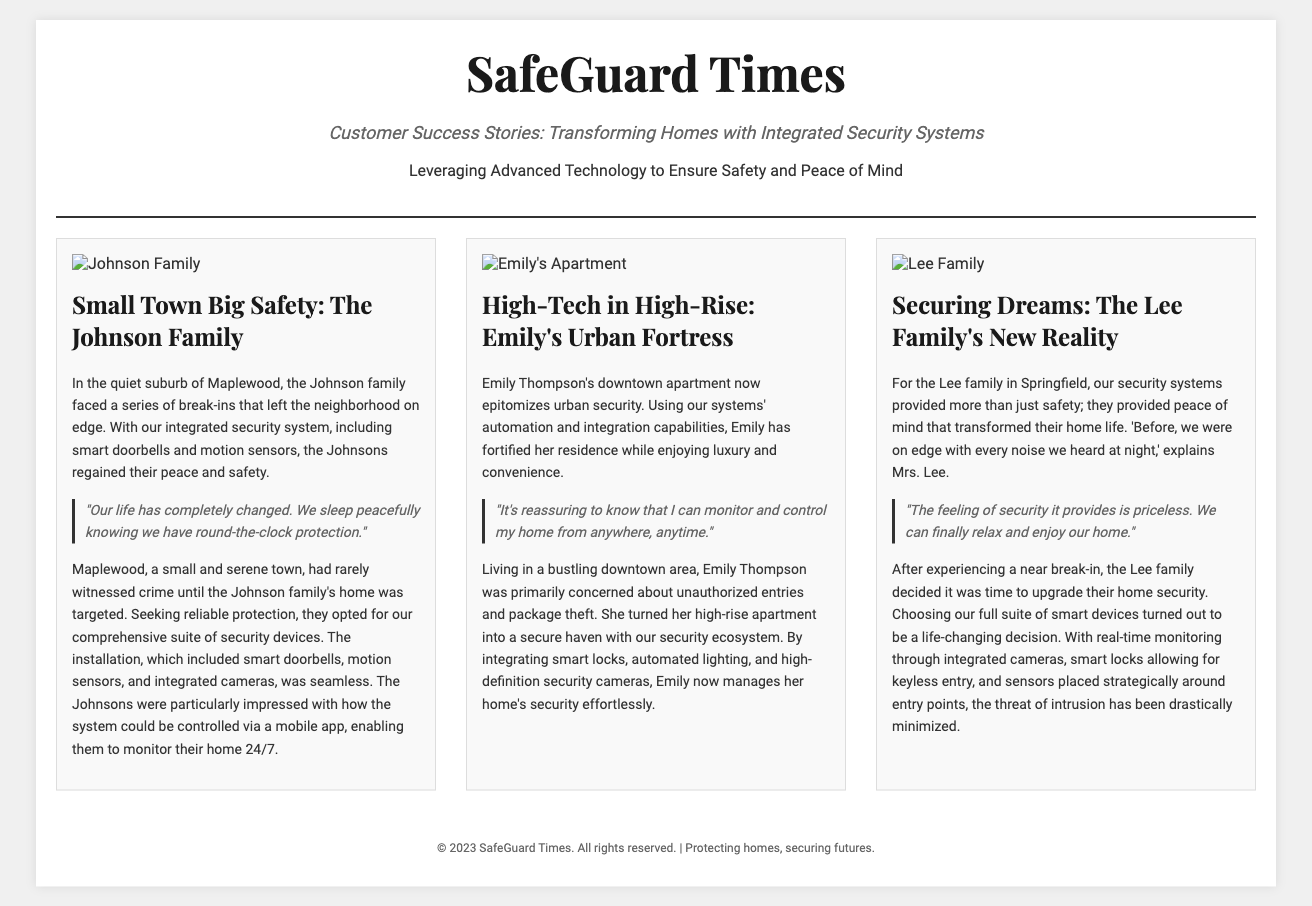What is the title of the article? The title of the article is prominently displayed at the top of the document.
Answer: SafeGuard Times Who is featured in the first success story? The first success story highlights a specific family living in a suburban area.
Answer: Johnson Family What type of security devices were installed for the Johnson family? The document specifies the types of devices used for security in the Johnson family's home.
Answer: Smart doorbells and motion sensors What city does Emily Thompson live in? The document mentions her living situation, reflecting the urban setting of her residence.
Answer: Downtown What quote did Mrs. Lee provide about her family's experience? The quote reflects the emotional impact of the security system on the Lee family.
Answer: "The feeling of security it provides is priceless." How many homes are highlighted in this article? The article discusses multiple success stories and provides a summary of each.
Answer: Three What is a unique feature of Emily's high-rise apartment security system? The article describes a particular aspect of the security arrangement for Emily's apartment.
Answer: Automated lighting What sentiment does the Johnson family express after installing the security system? The document describes the emotional response of the Johnson family post-installation.
Answer: Peace and safety 